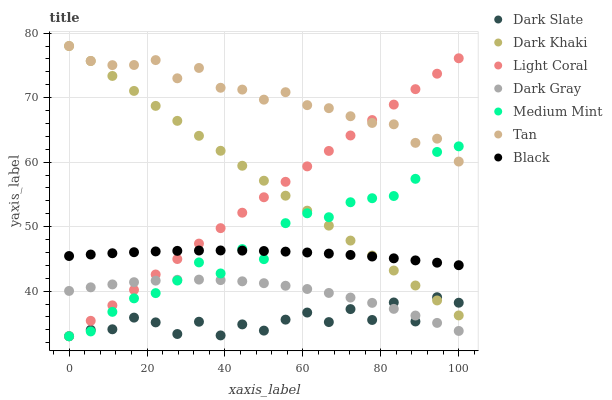Does Dark Slate have the minimum area under the curve?
Answer yes or no. Yes. Does Tan have the maximum area under the curve?
Answer yes or no. Yes. Does Dark Gray have the minimum area under the curve?
Answer yes or no. No. Does Dark Gray have the maximum area under the curve?
Answer yes or no. No. Is Dark Khaki the smoothest?
Answer yes or no. Yes. Is Dark Slate the roughest?
Answer yes or no. Yes. Is Dark Gray the smoothest?
Answer yes or no. No. Is Dark Gray the roughest?
Answer yes or no. No. Does Medium Mint have the lowest value?
Answer yes or no. Yes. Does Dark Gray have the lowest value?
Answer yes or no. No. Does Tan have the highest value?
Answer yes or no. Yes. Does Dark Gray have the highest value?
Answer yes or no. No. Is Dark Slate less than Black?
Answer yes or no. Yes. Is Tan greater than Black?
Answer yes or no. Yes. Does Dark Gray intersect Dark Slate?
Answer yes or no. Yes. Is Dark Gray less than Dark Slate?
Answer yes or no. No. Is Dark Gray greater than Dark Slate?
Answer yes or no. No. Does Dark Slate intersect Black?
Answer yes or no. No. 